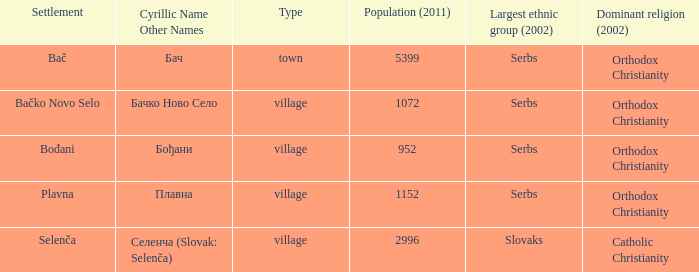What is the second way of writting плавна. Plavna. 